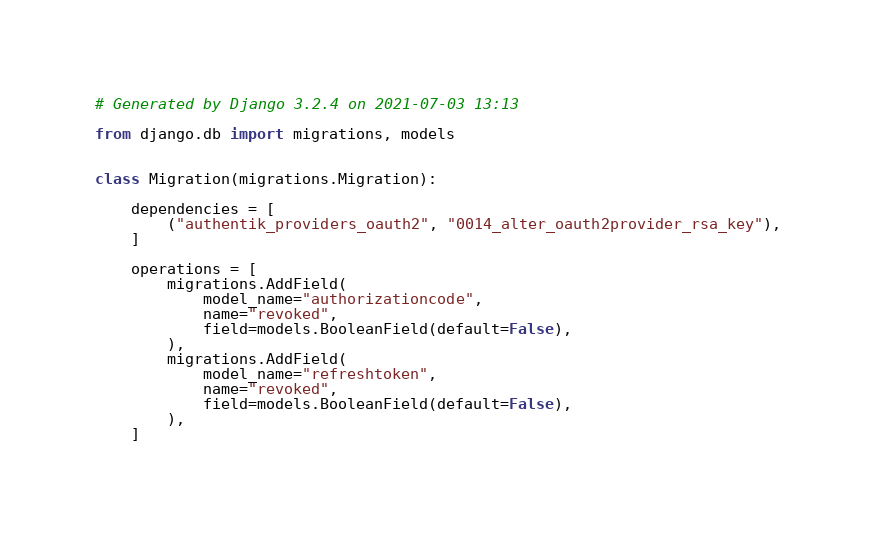Convert code to text. <code><loc_0><loc_0><loc_500><loc_500><_Python_># Generated by Django 3.2.4 on 2021-07-03 13:13

from django.db import migrations, models


class Migration(migrations.Migration):

    dependencies = [
        ("authentik_providers_oauth2", "0014_alter_oauth2provider_rsa_key"),
    ]

    operations = [
        migrations.AddField(
            model_name="authorizationcode",
            name="revoked",
            field=models.BooleanField(default=False),
        ),
        migrations.AddField(
            model_name="refreshtoken",
            name="revoked",
            field=models.BooleanField(default=False),
        ),
    ]
</code> 